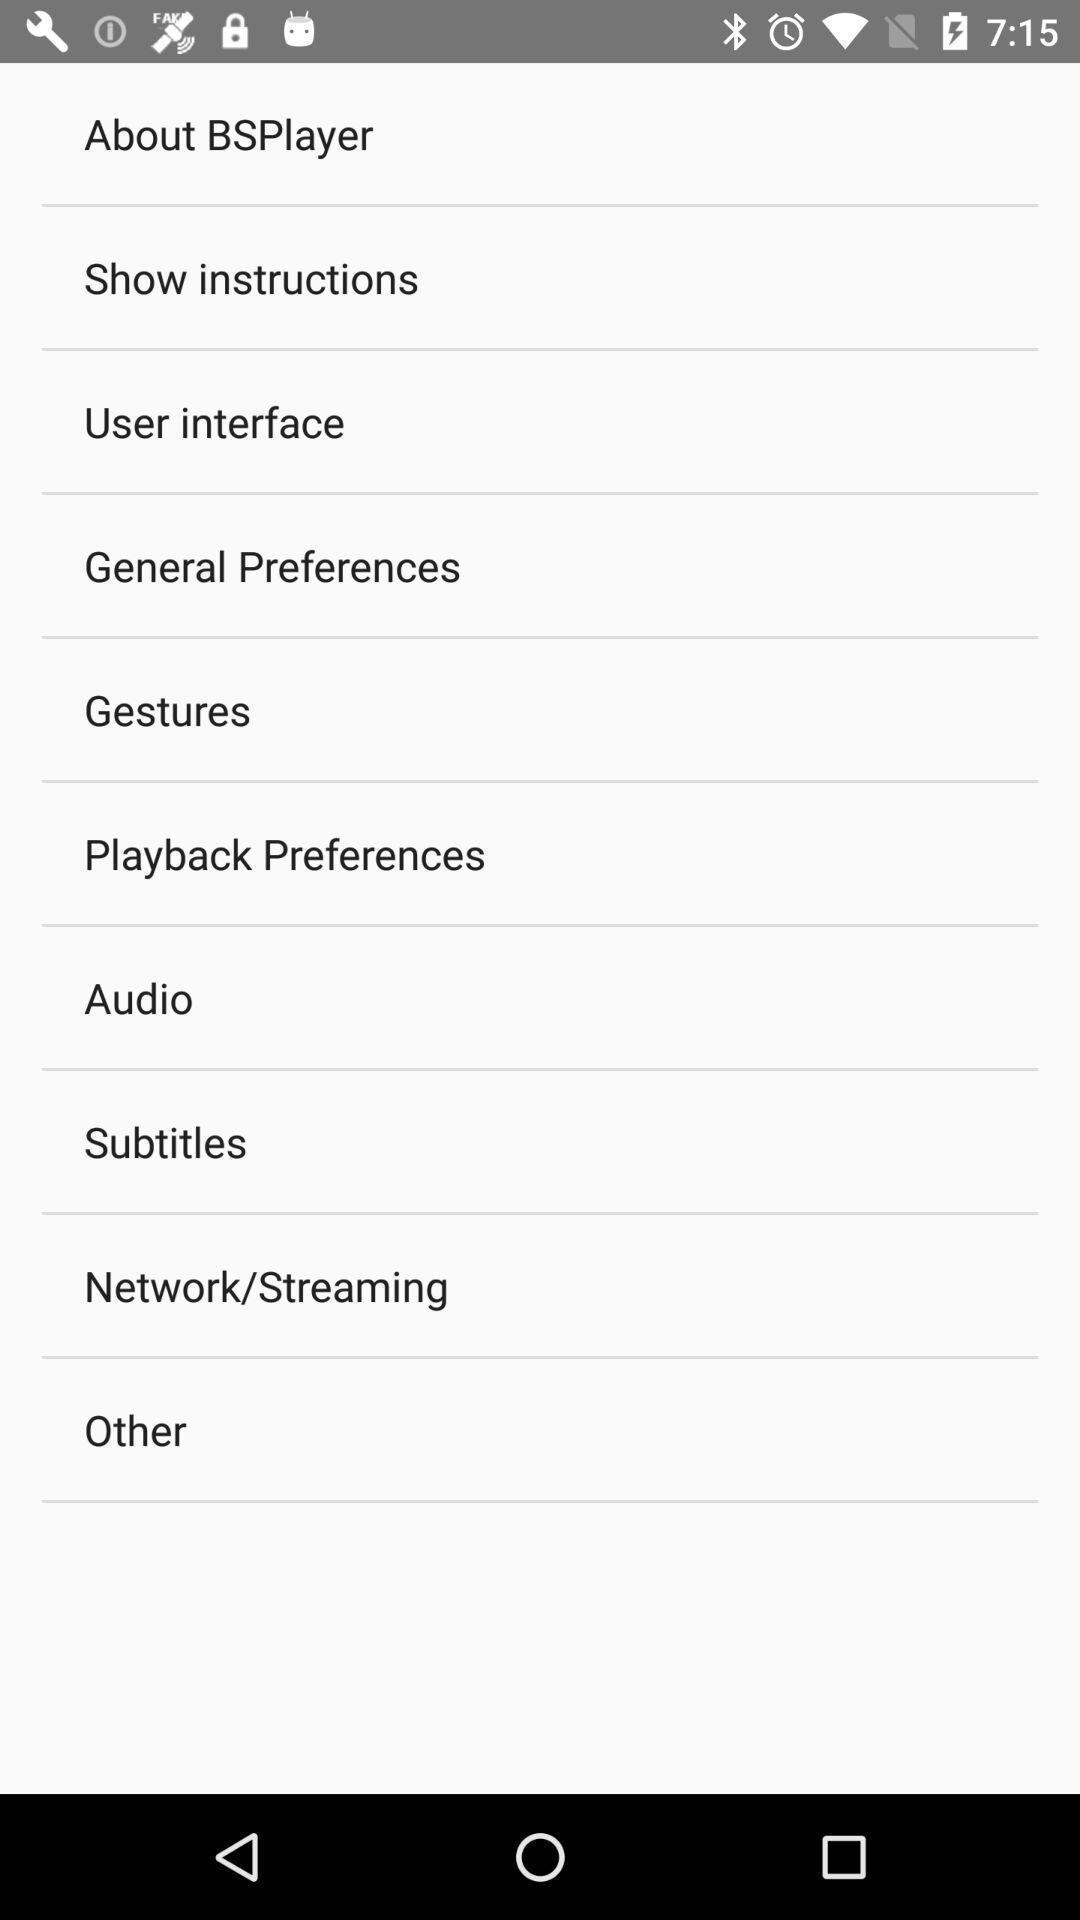Describe this image in words. Screen displaying multiple options in a video player application. 